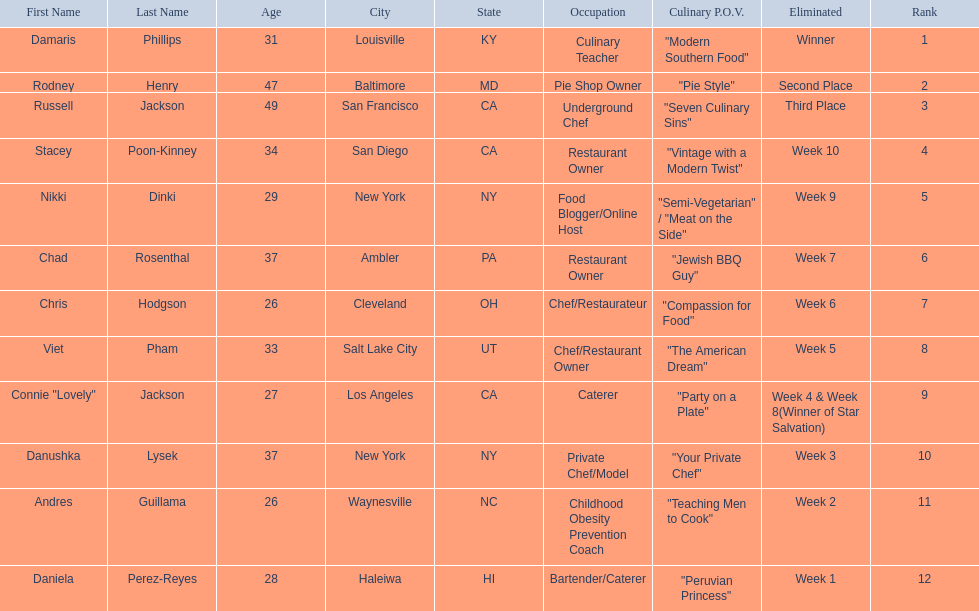Who are the listed food network star contestants? Damaris Phillips, Rodney Henry, Russell Jackson, Stacey Poon-Kinney, Nikki Dinki, Chad Rosenthal, Chris Hodgson, Viet Pham, Connie "Lovely" Jackson, Danushka Lysek, Andres Guillama, Daniela Perez-Reyes. Of those who had the longest p.o.v title? Nikki Dinki. 